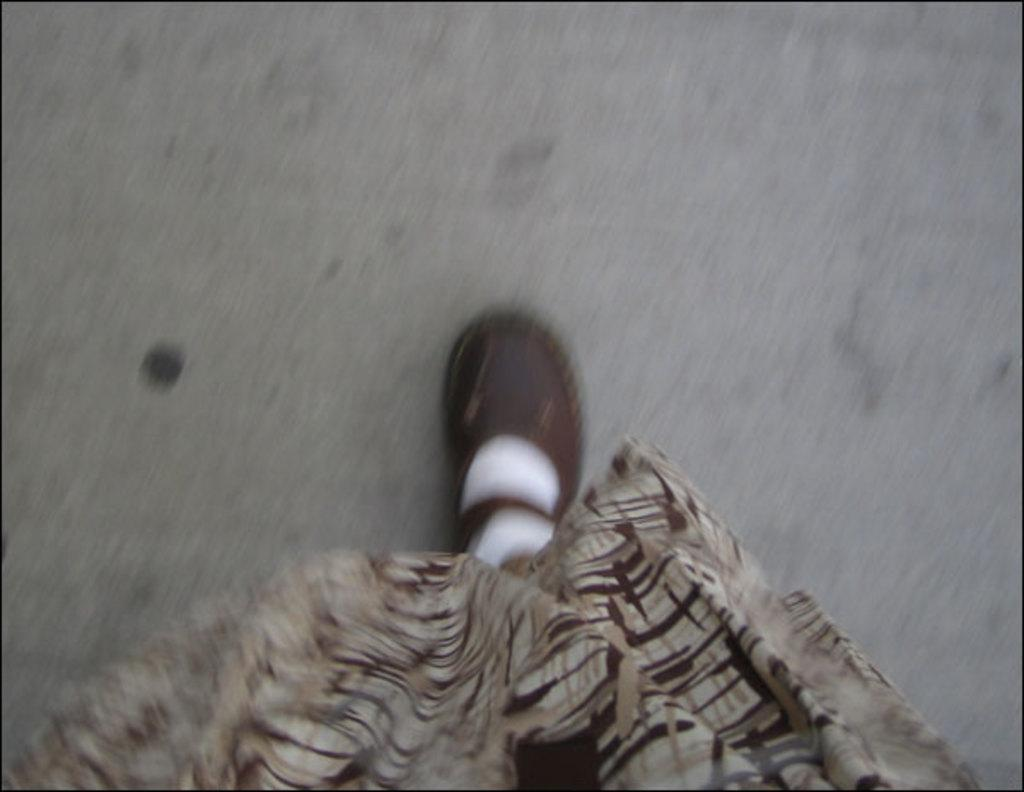What part of a person can be seen in the image? There is a leg of a person with a shoe in the image. What type of object is present in the image besides the leg? There is a cloth in the image. How would you describe the background of the image? The background of the image is blurred. What type of sail can be seen in the image? There is no sail present in the image. How does the person in the image roll their hair? There is no indication of hair or rolling in the image. 